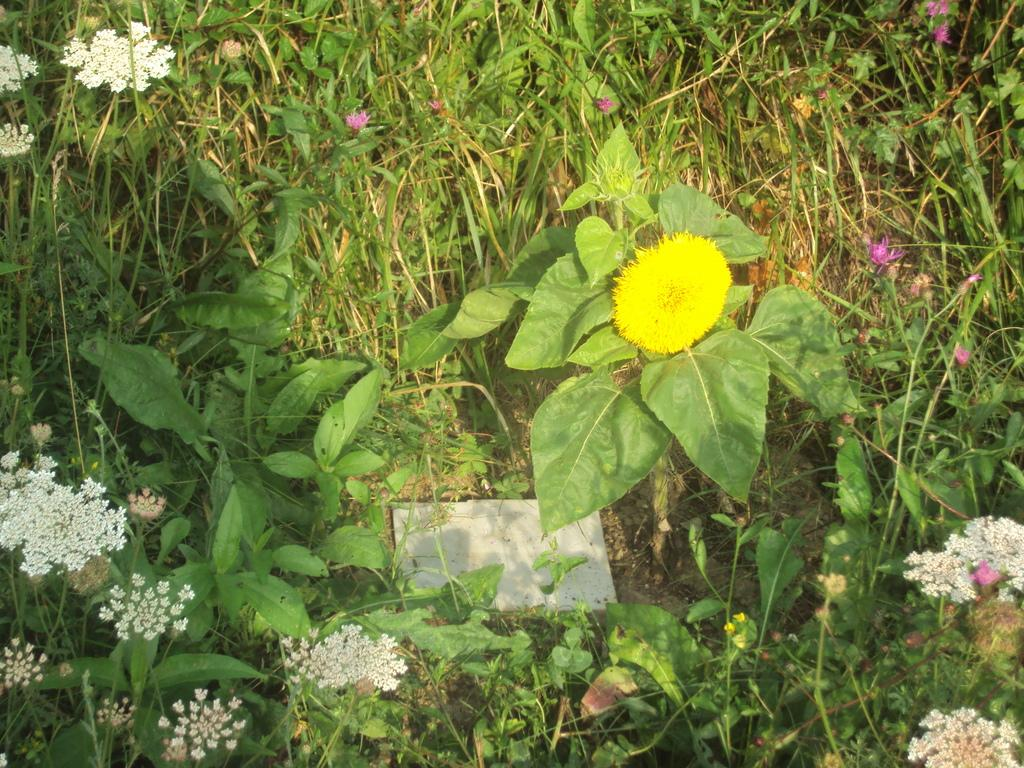What colors are the flowers in the image? The flowers in the image are white and yellow. What are the flowers attached to? The flowers are on plants. What can be seen growing in the image? There are plants in the image. What type of notebook is visible on the slope in the image? There is no notebook or slope present in the image; it features white and yellow flowers on plants. 